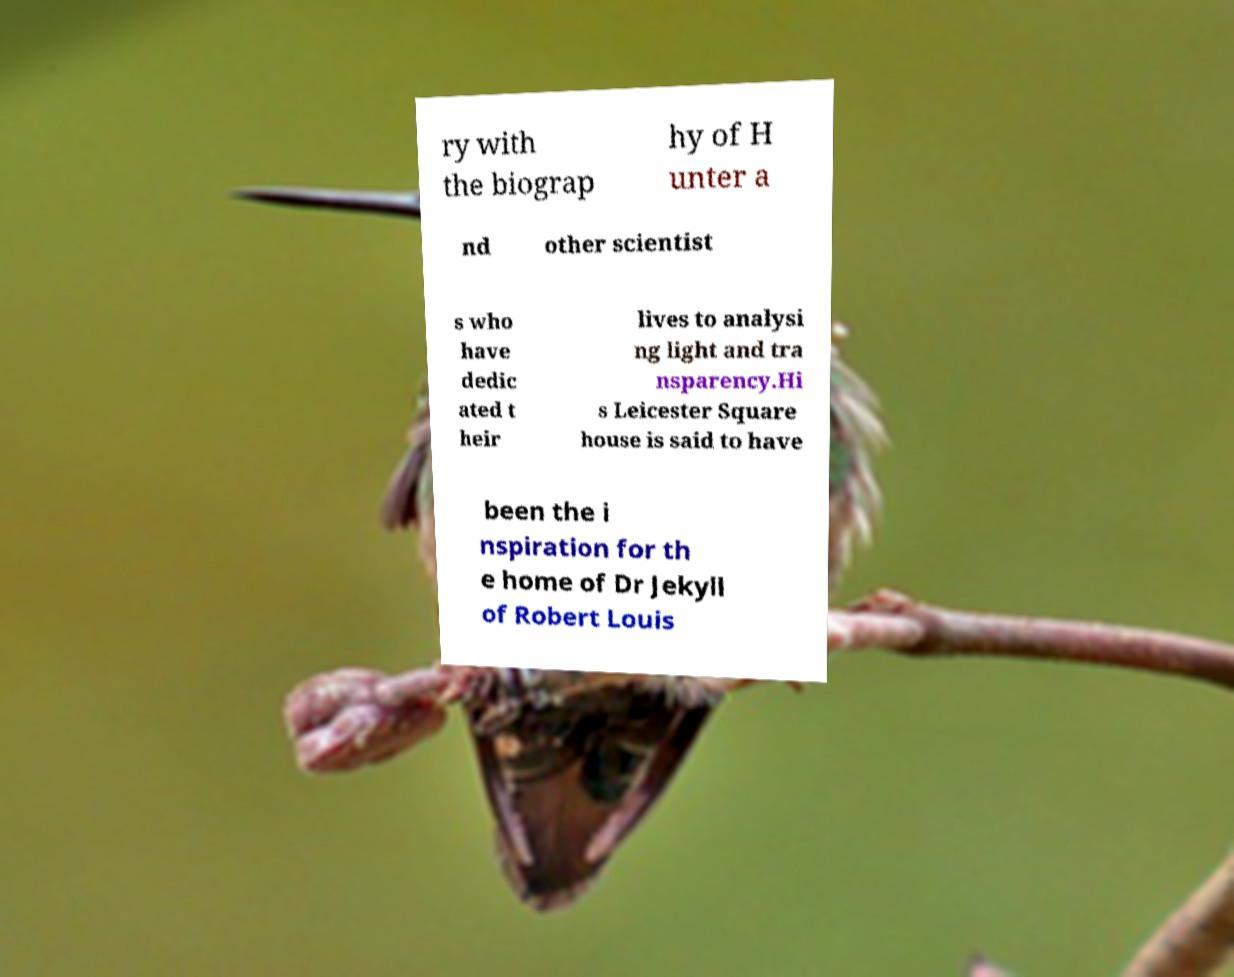What messages or text are displayed in this image? I need them in a readable, typed format. ry with the biograp hy of H unter a nd other scientist s who have dedic ated t heir lives to analysi ng light and tra nsparency.Hi s Leicester Square house is said to have been the i nspiration for th e home of Dr Jekyll of Robert Louis 